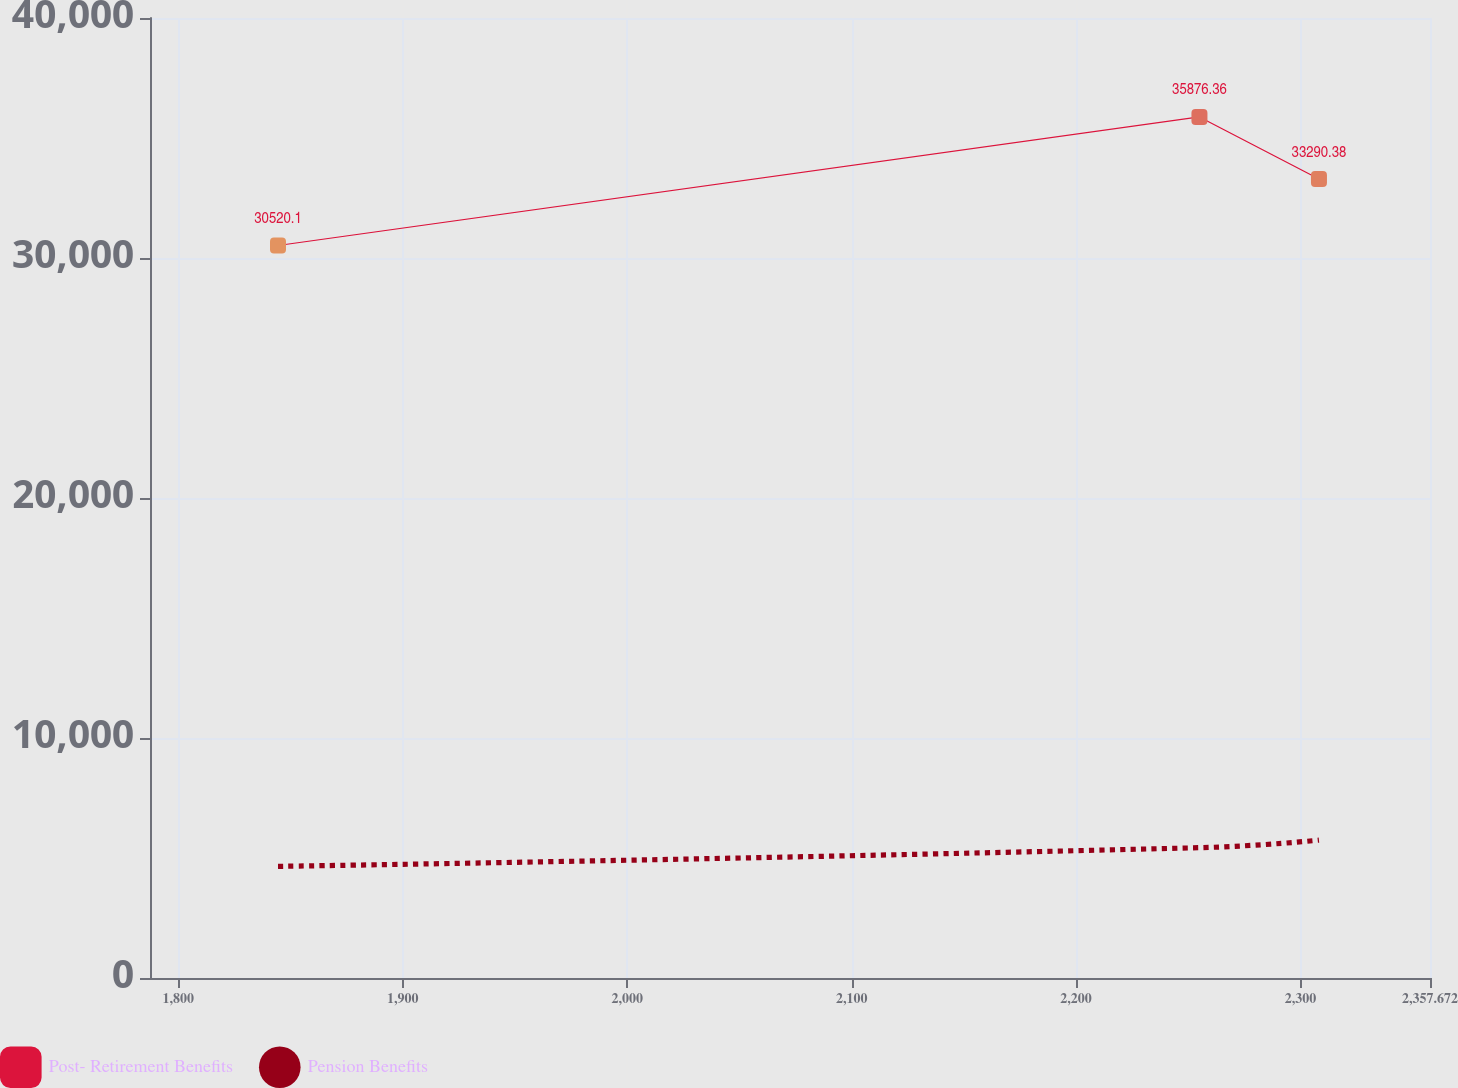Convert chart. <chart><loc_0><loc_0><loc_500><loc_500><line_chart><ecel><fcel>Post- Retirement Benefits<fcel>Pension Benefits<nl><fcel>1844.42<fcel>30520.1<fcel>4650.8<nl><fcel>2254.95<fcel>35876.4<fcel>5429.92<nl><fcel>2308.2<fcel>33290.4<fcel>5743.86<nl><fcel>2361.45<fcel>40936.4<fcel>4227.32<nl><fcel>2414.7<fcel>29081.8<fcel>4802.45<nl></chart> 